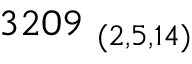Convert formula to latex. <formula><loc_0><loc_0><loc_500><loc_500>3 2 0 9 _ { \ ( 2 , 5 , 1 4 ) }</formula> 